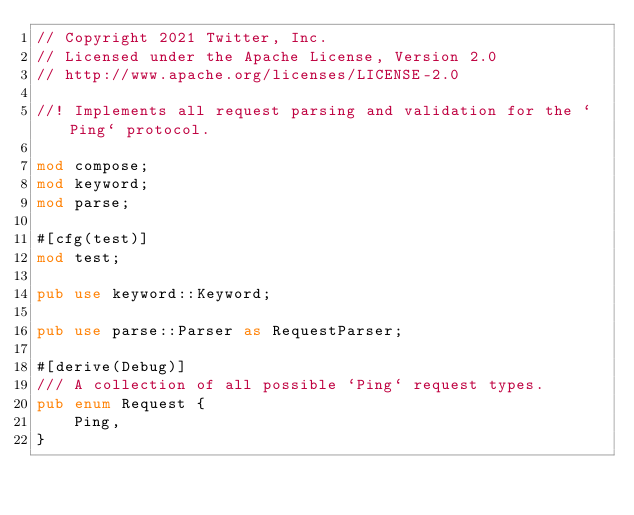<code> <loc_0><loc_0><loc_500><loc_500><_Rust_>// Copyright 2021 Twitter, Inc.
// Licensed under the Apache License, Version 2.0
// http://www.apache.org/licenses/LICENSE-2.0

//! Implements all request parsing and validation for the `Ping` protocol.

mod compose;
mod keyword;
mod parse;

#[cfg(test)]
mod test;

pub use keyword::Keyword;

pub use parse::Parser as RequestParser;

#[derive(Debug)]
/// A collection of all possible `Ping` request types.
pub enum Request {
    Ping,
}
</code> 